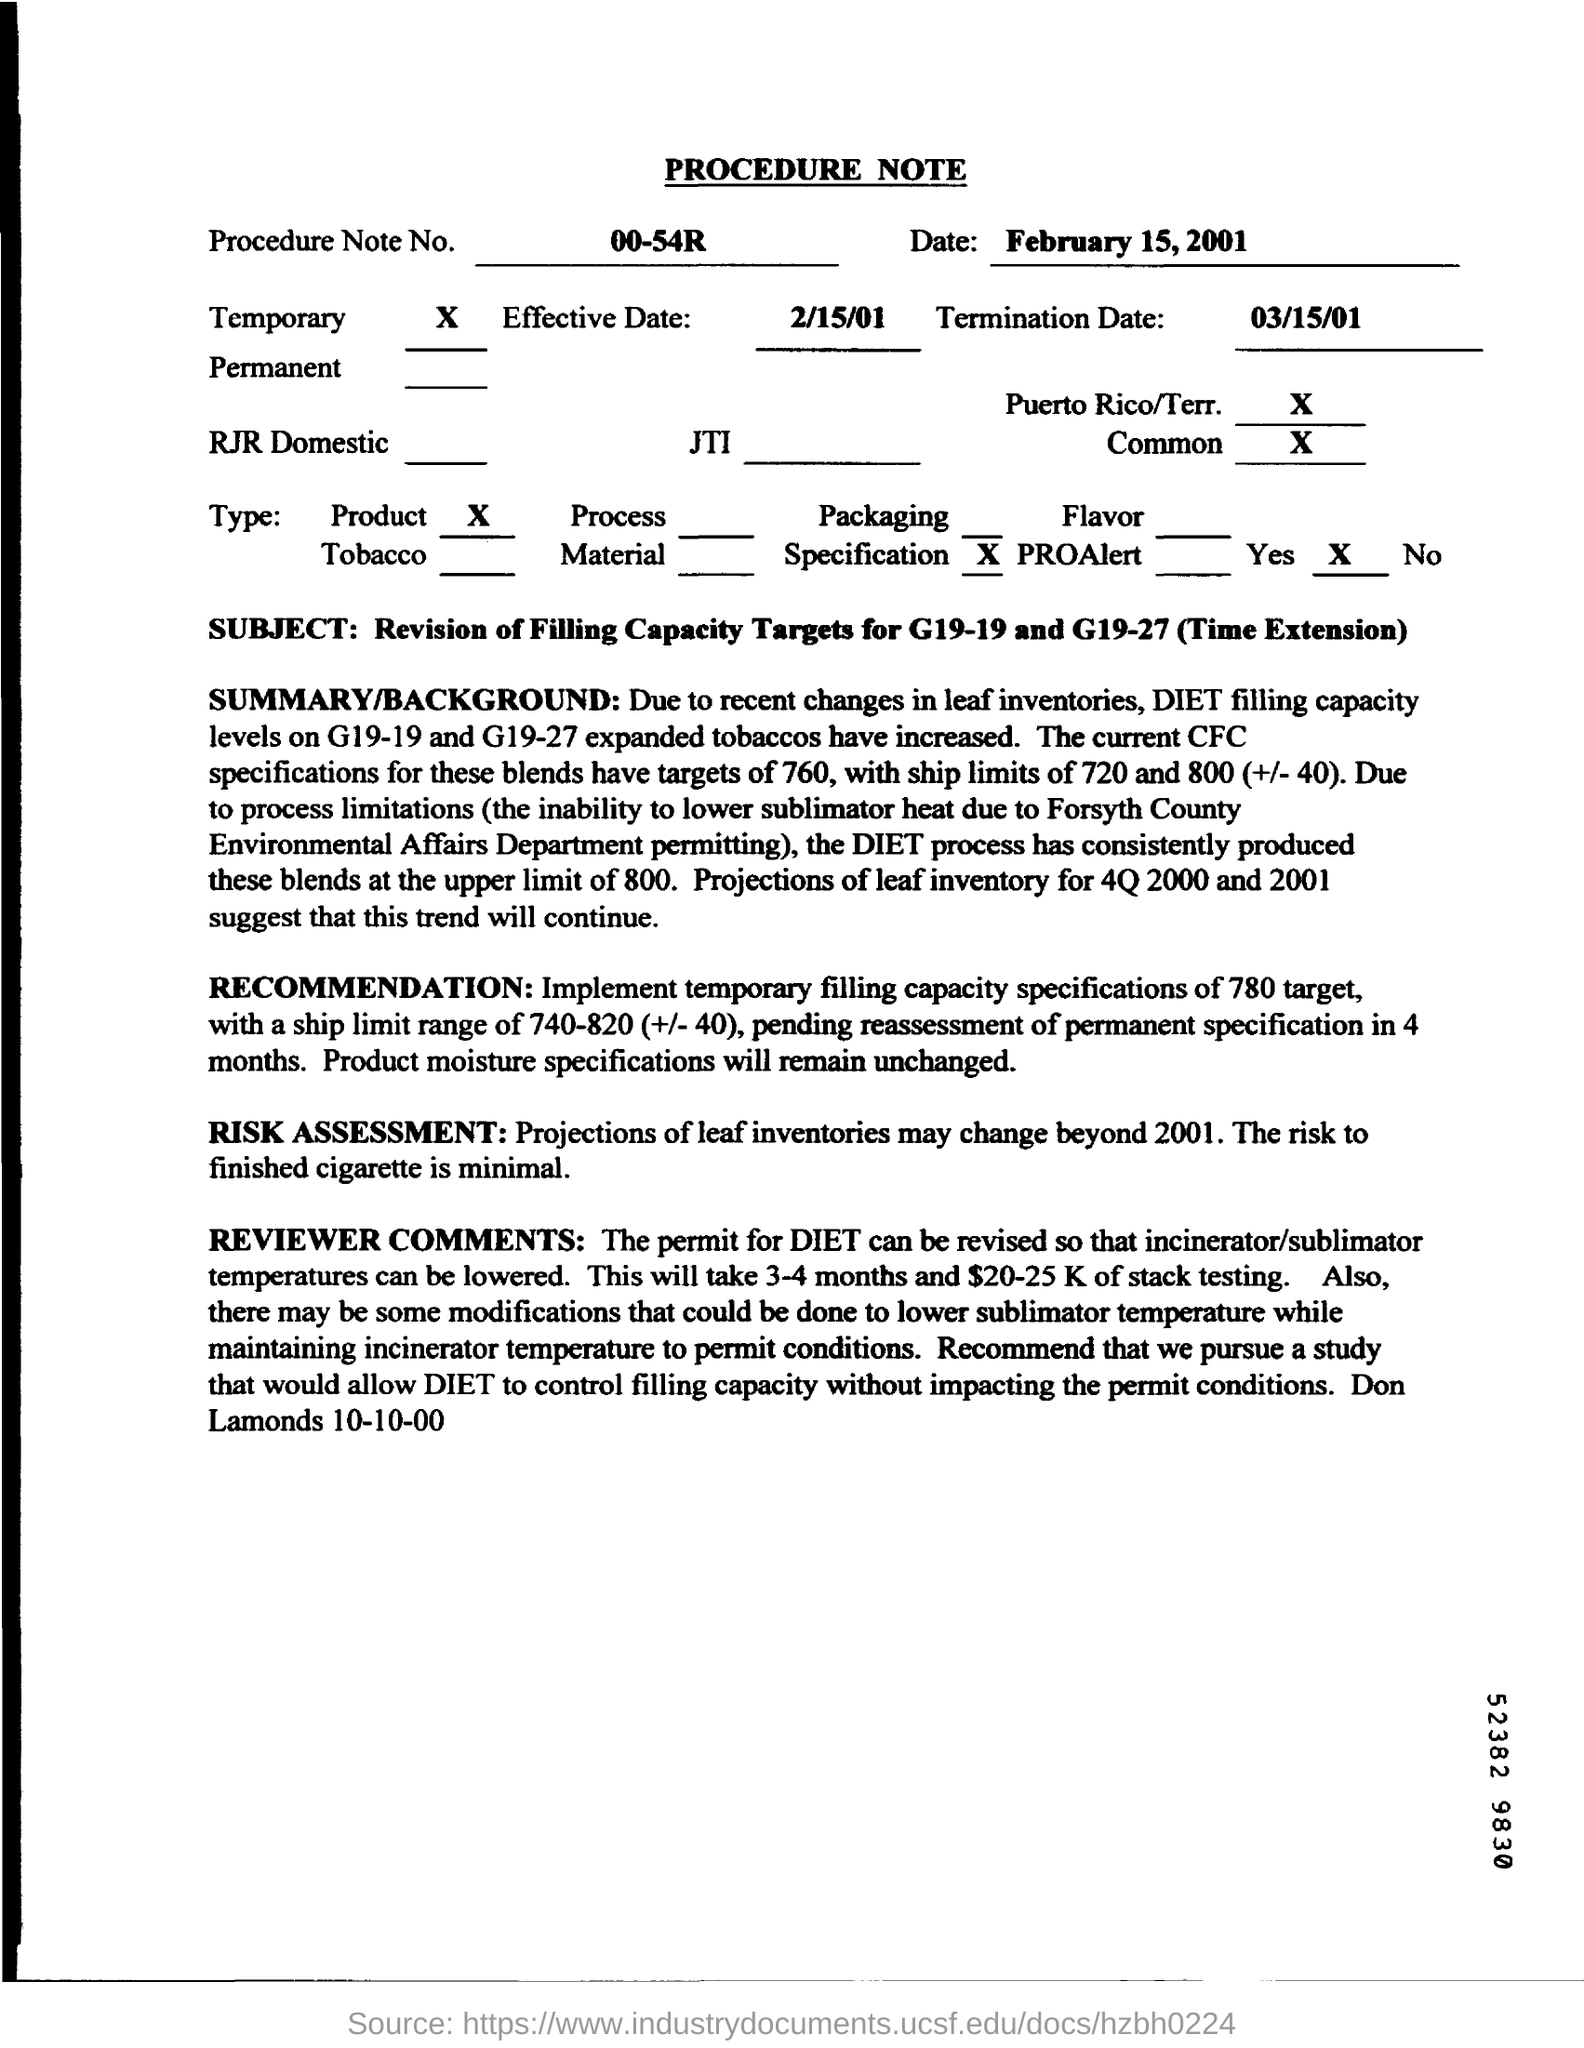What is the subject mentioned in the procedure note?
Your response must be concise. Revision of filling capacity targets for G19-19 and G19-27 (Time Extension). What is the procedure note no.?
Offer a terse response. 00-54R. What will remain unchanged in RECOMMENDATION?
Give a very brief answer. Product moisture specifications. What is  the reason for which permits for DIET should be revised?
Give a very brief answer. So that the incinerator/ sublimator temperatures can be lowered. How many months will it take for stack testing?
Ensure brevity in your answer.  3-4 months. 